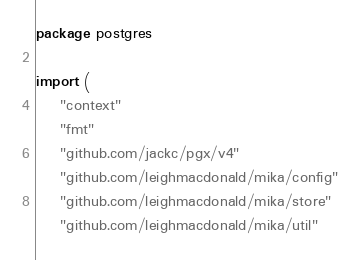<code> <loc_0><loc_0><loc_500><loc_500><_Go_>package postgres

import (
	"context"
	"fmt"
	"github.com/jackc/pgx/v4"
	"github.com/leighmacdonald/mika/config"
	"github.com/leighmacdonald/mika/store"
	"github.com/leighmacdonald/mika/util"</code> 